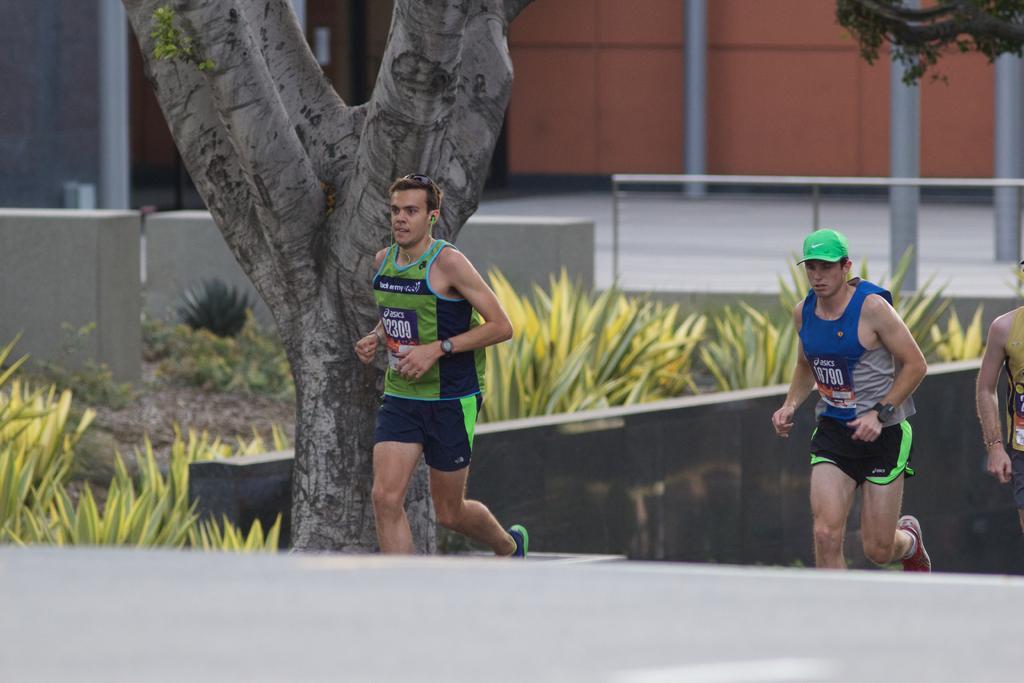How would you summarize this image in a sentence or two? In this image I can see there are few persons jogging and they are wearing green shirts and trousers, the person at right is wearing a cap. There are plants and there is a building in the backdrop. 